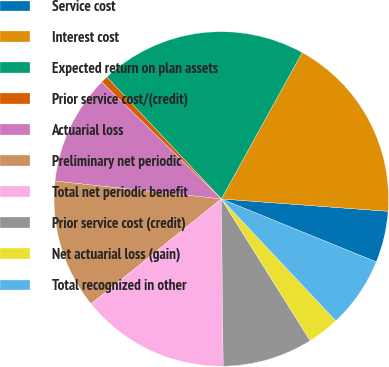<chart> <loc_0><loc_0><loc_500><loc_500><pie_chart><fcel>Service cost<fcel>Interest cost<fcel>Expected return on plan assets<fcel>Prior service cost/(credit)<fcel>Actuarial loss<fcel>Preliminary net periodic<fcel>Total net periodic benefit<fcel>Prior service cost (credit)<fcel>Net actuarial loss (gain)<fcel>Total recognized in other<nl><fcel>4.97%<fcel>18.15%<fcel>20.03%<fcel>0.68%<fcel>10.62%<fcel>12.5%<fcel>14.38%<fcel>8.73%<fcel>3.09%<fcel>6.85%<nl></chart> 